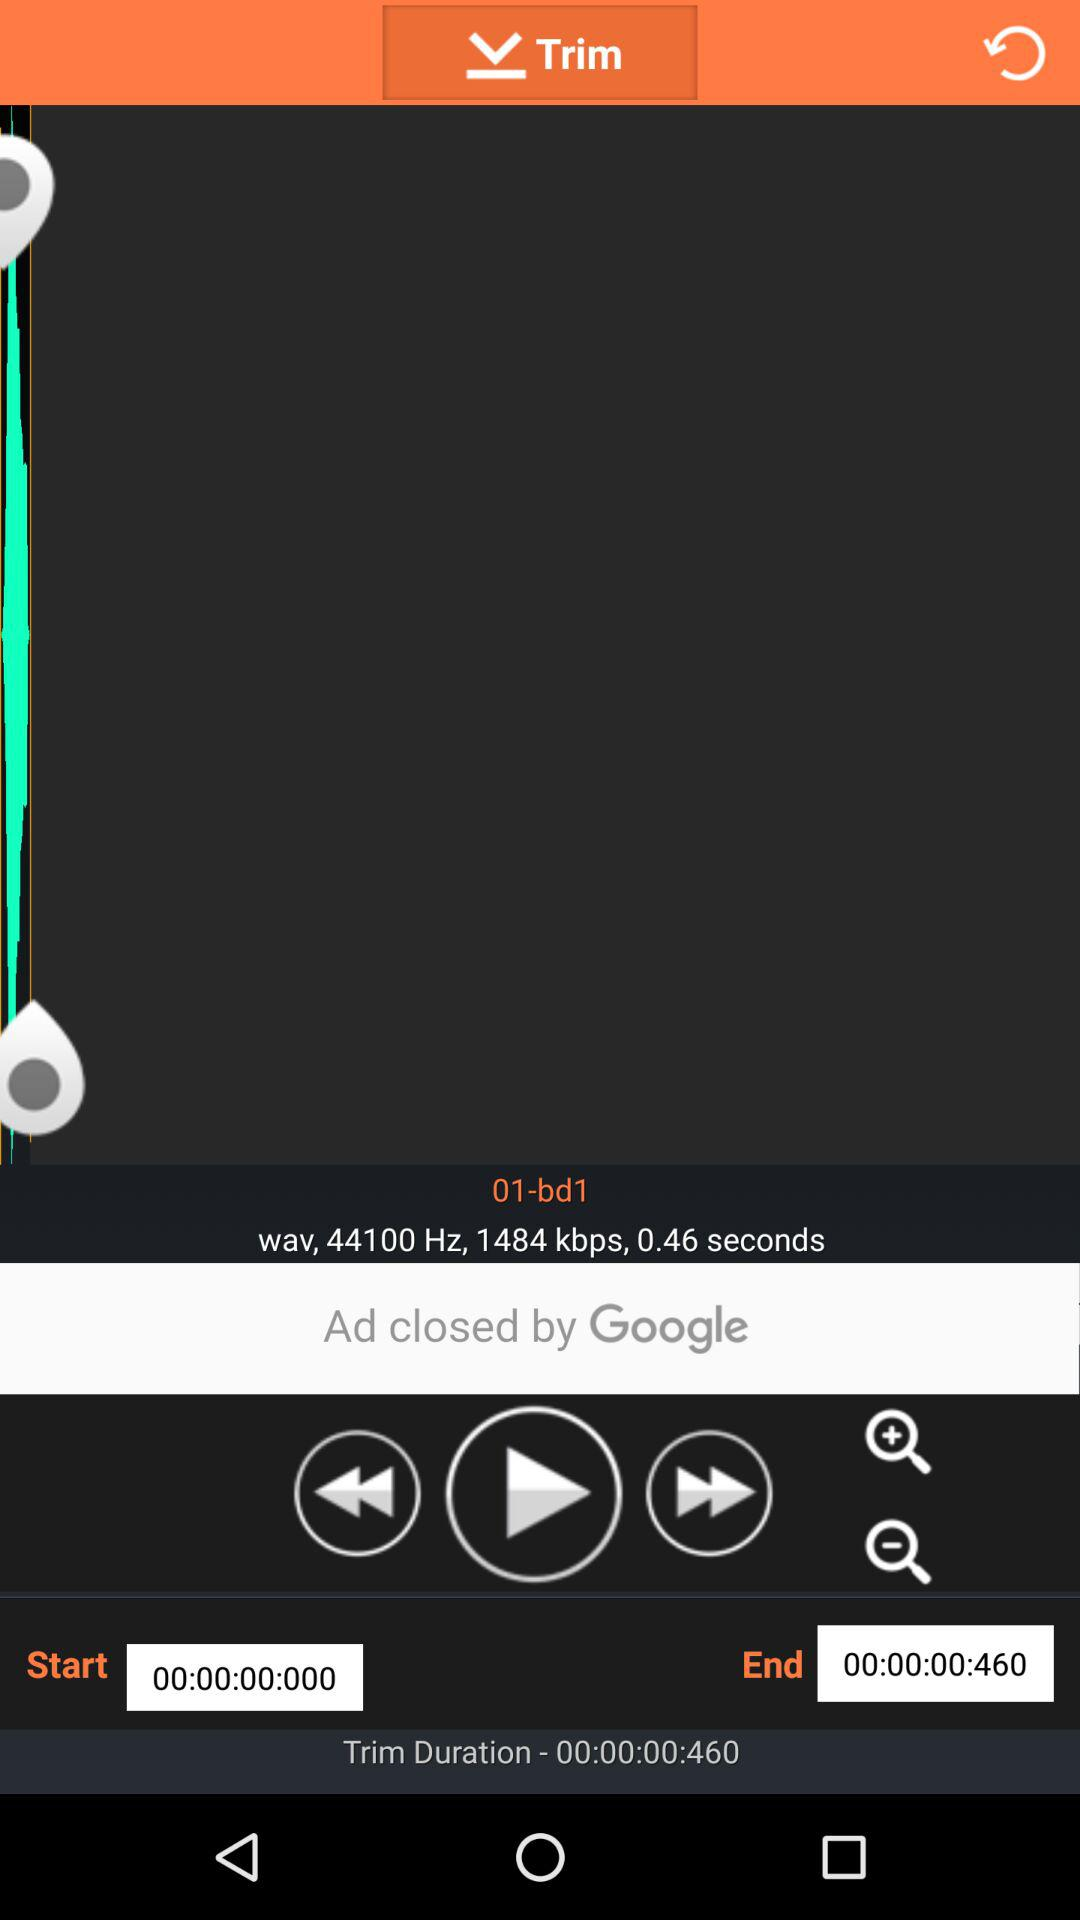What is the end time? The end time is 00:00:00:460. 